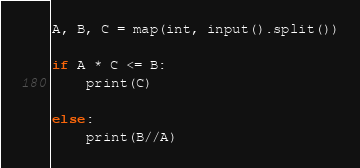<code> <loc_0><loc_0><loc_500><loc_500><_Python_>A, B, C = map(int, input().split())

if A * C <= B:
    print(C)

else:
    print(B//A)
</code> 